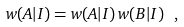<formula> <loc_0><loc_0><loc_500><loc_500>w ( A | I ) = w ( A | I ) \, w ( B | I ) \ ,</formula> 